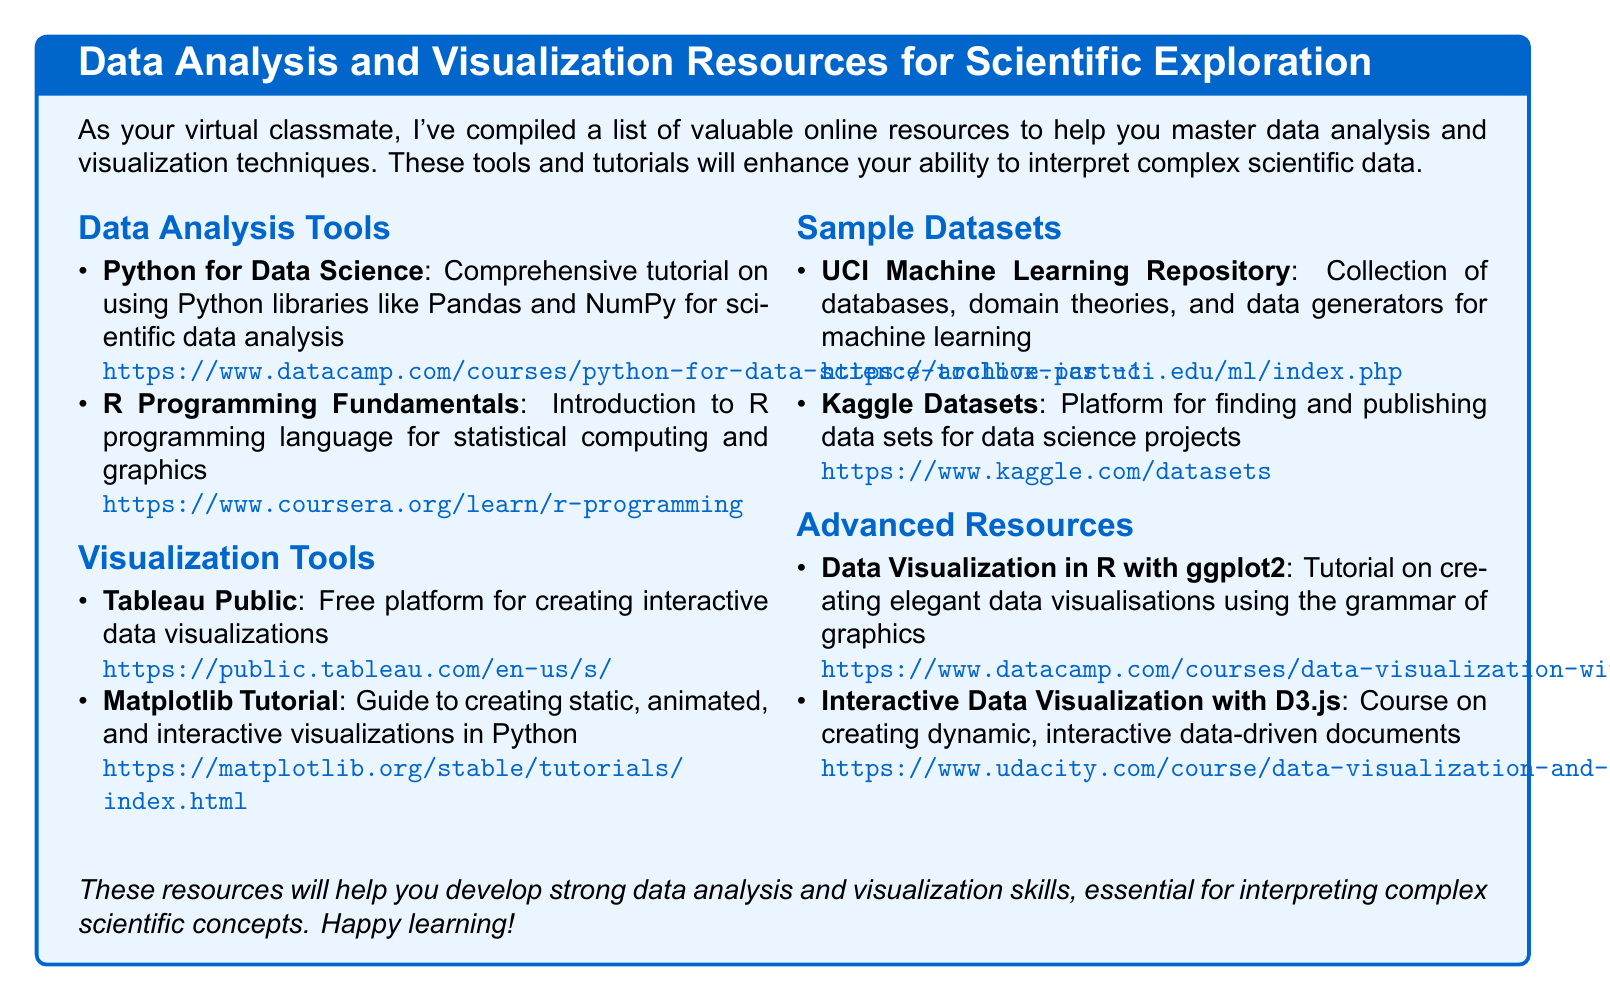What is the title of the document? The title of the document is presented in the tcolorbox at the top, signifying its purpose and content.
Answer: Data Analysis and Visualization Resources for Scientific Exploration How many tutorial resources are listed under Data Analysis Tools? The number of tutorial resources in each section can be counted directly from the list provided.
Answer: 2 What is the URL for the Tableau Public resource? The URL for the Tableau Public resource is explicitly stated next to the resource name in the document.
Answer: https://public.tableau.com/en-us/s/ Which programming language is introduced in the R Programming Fundamentals resource? The programming language being introduced can be identified from the description of the resource.
Answer: R What is one sample dataset source mentioned in the document? The sources for sample datasets can be found listed under the Sample Datasets section.
Answer: UCI Machine Learning Repository How many resources are listed under Advanced Resources? The total number of resources can be determined by counting the listed items in the respective section.
Answer: 2 What is the main visual tool discussed in the Matplotlib Tutorial? The main aspect covered in the tutorial can be derived from its description in relation to other visual tools.
Answer: Visualizations Which educational platform offers the course on Interactive Data Visualization with D3.js? The name of the platform providing the course is stated alongside the course information.
Answer: Udacity 